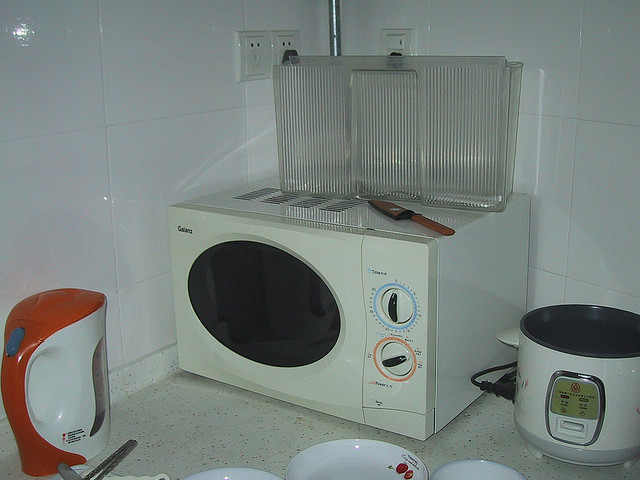<image>What is the red and white thing? It is ambiguous what the red and white thing is. It could be a coffee maker, cup, heater, pitcher, water boiler, trash can, drink holder, humidifier, or an iron. What is the red and white thing? I don't know what the red and white thing is. It could be a coffee maker, cup, heater, pitcher, water boiler, trash can, drink holder, humidifier, or iron. 